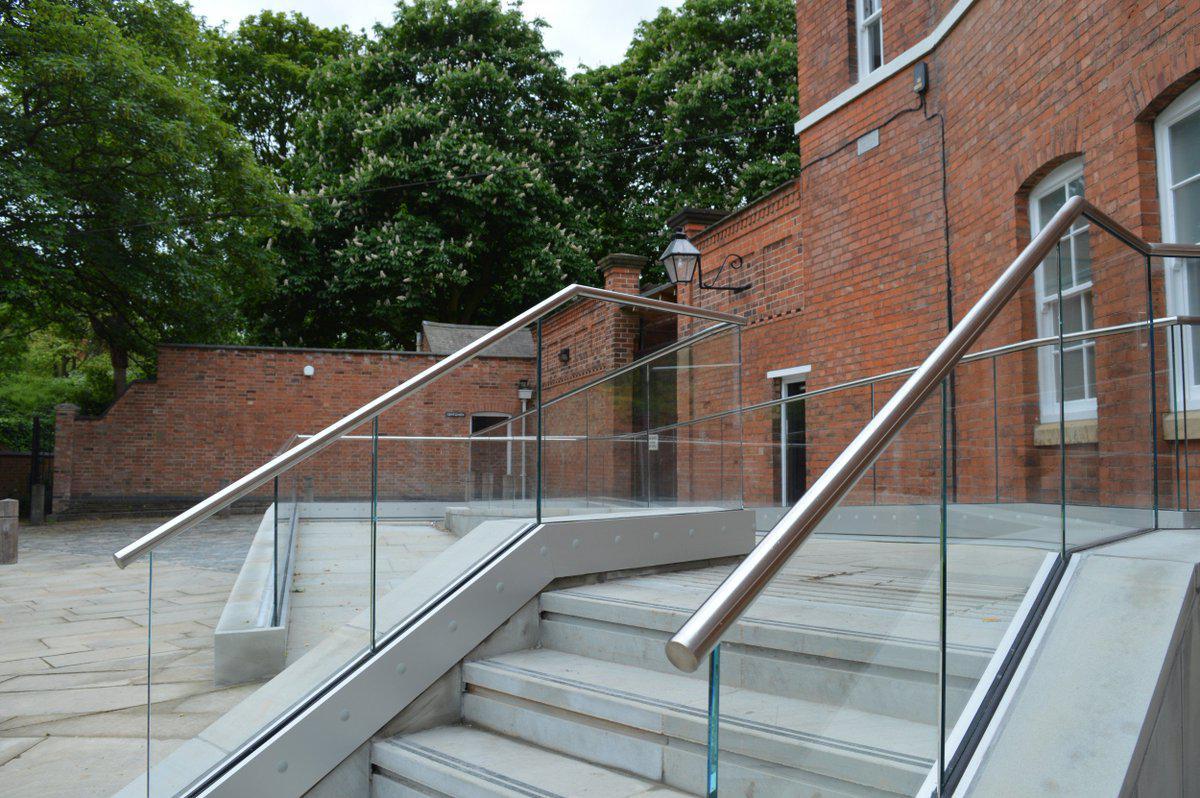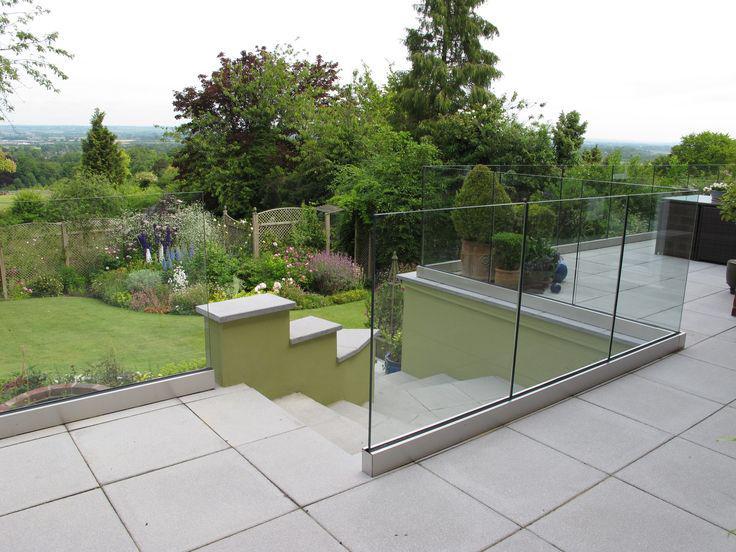The first image is the image on the left, the second image is the image on the right. For the images shown, is this caption "The right image shows a straight metal rail with vertical bars at the edge of a stained brown plank deck that overlooks dense foliage and trees." true? Answer yes or no. No. 